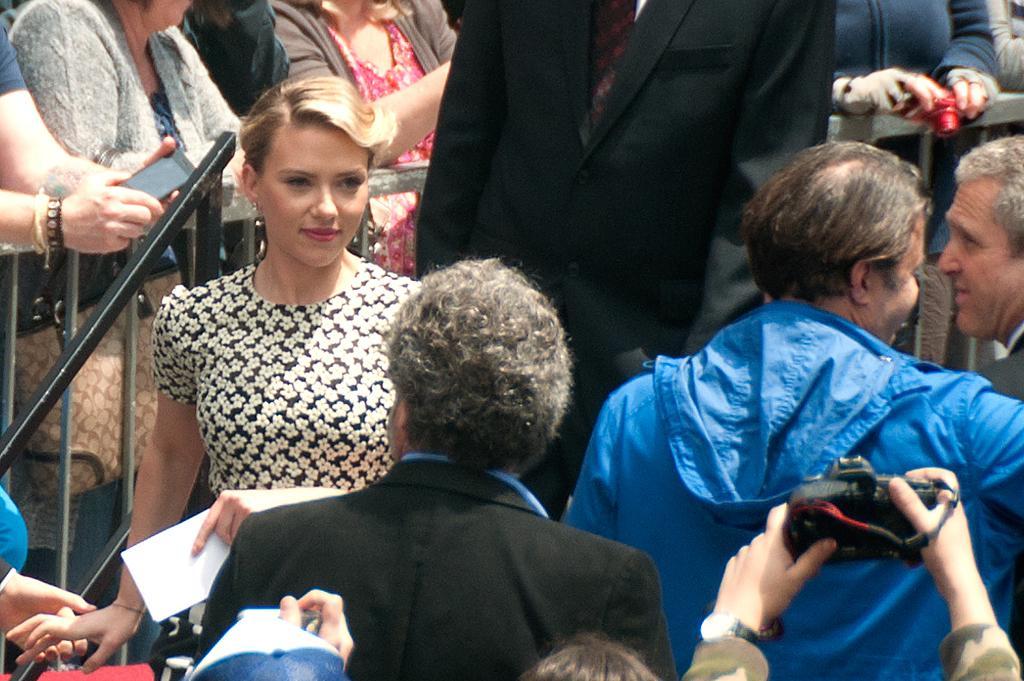Can you describe this image briefly? In this picture we can see many people. There are a few people holding objects in their hands. We can see a fence from left to right. 